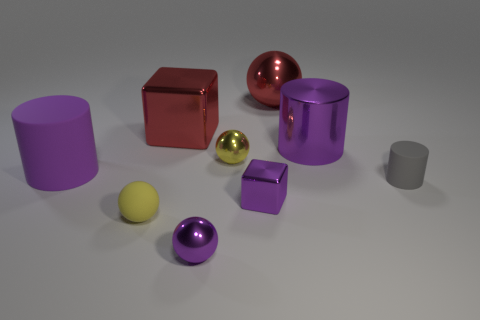There is a big purple rubber object in front of the big cube; is it the same shape as the matte thing that is in front of the tiny shiny cube?
Your response must be concise. No. The yellow object that is on the left side of the small purple shiny ball that is on the right side of the red cube is what shape?
Ensure brevity in your answer.  Sphere. There is another cylinder that is the same color as the large matte cylinder; what size is it?
Your response must be concise. Large. Are there any other big spheres made of the same material as the red ball?
Provide a succinct answer. No. What material is the purple cylinder that is on the right side of the small purple cube?
Make the answer very short. Metal. What is the purple sphere made of?
Offer a terse response. Metal. Are the yellow object to the right of the yellow matte thing and the large red block made of the same material?
Your response must be concise. Yes. Are there fewer large purple metallic objects behind the large red block than rubber cylinders?
Your answer should be compact. Yes. The metal sphere that is the same size as the red shiny cube is what color?
Your answer should be very brief. Red. How many large purple matte things have the same shape as the small gray thing?
Your answer should be very brief. 1. 